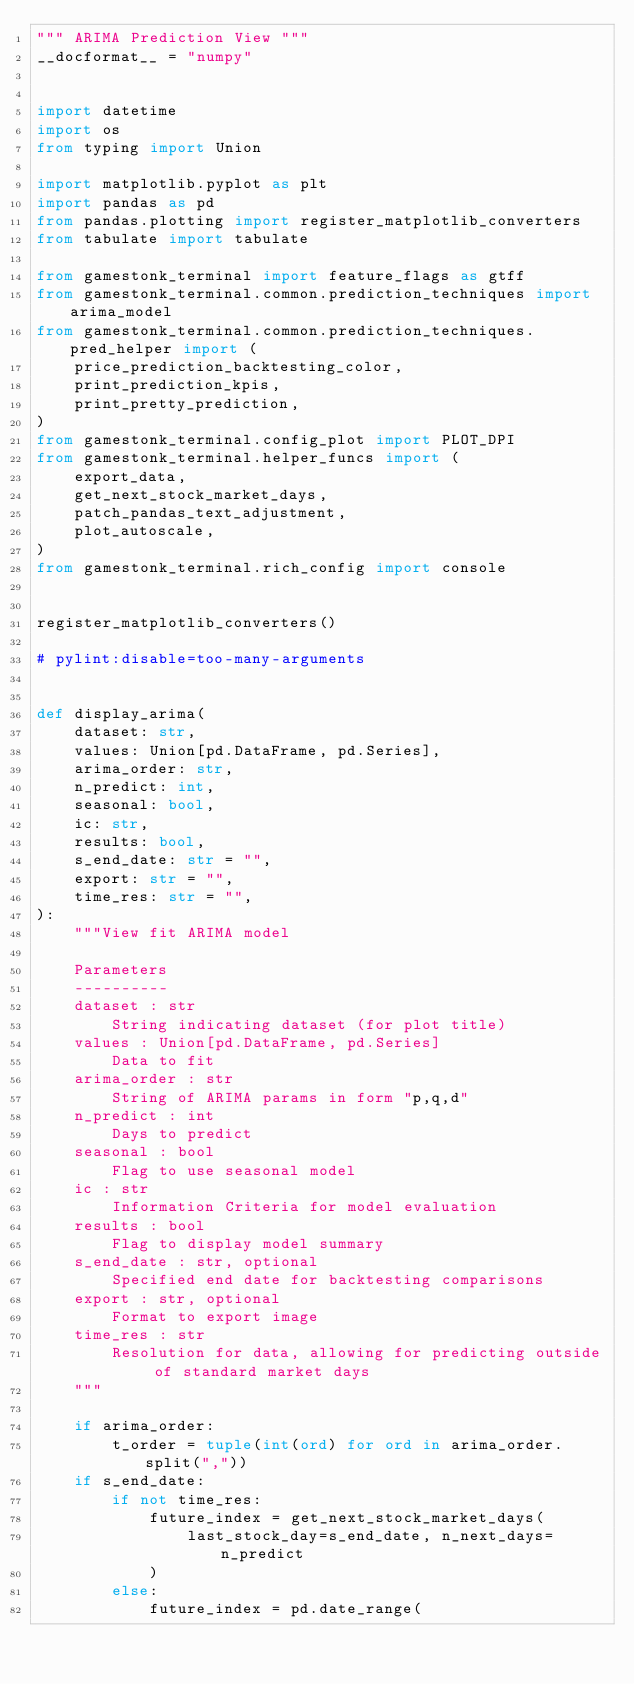Convert code to text. <code><loc_0><loc_0><loc_500><loc_500><_Python_>""" ARIMA Prediction View """
__docformat__ = "numpy"


import datetime
import os
from typing import Union

import matplotlib.pyplot as plt
import pandas as pd
from pandas.plotting import register_matplotlib_converters
from tabulate import tabulate

from gamestonk_terminal import feature_flags as gtff
from gamestonk_terminal.common.prediction_techniques import arima_model
from gamestonk_terminal.common.prediction_techniques.pred_helper import (
    price_prediction_backtesting_color,
    print_prediction_kpis,
    print_pretty_prediction,
)
from gamestonk_terminal.config_plot import PLOT_DPI
from gamestonk_terminal.helper_funcs import (
    export_data,
    get_next_stock_market_days,
    patch_pandas_text_adjustment,
    plot_autoscale,
)
from gamestonk_terminal.rich_config import console


register_matplotlib_converters()

# pylint:disable=too-many-arguments


def display_arima(
    dataset: str,
    values: Union[pd.DataFrame, pd.Series],
    arima_order: str,
    n_predict: int,
    seasonal: bool,
    ic: str,
    results: bool,
    s_end_date: str = "",
    export: str = "",
    time_res: str = "",
):
    """View fit ARIMA model

    Parameters
    ----------
    dataset : str
        String indicating dataset (for plot title)
    values : Union[pd.DataFrame, pd.Series]
        Data to fit
    arima_order : str
        String of ARIMA params in form "p,q,d"
    n_predict : int
        Days to predict
    seasonal : bool
        Flag to use seasonal model
    ic : str
        Information Criteria for model evaluation
    results : bool
        Flag to display model summary
    s_end_date : str, optional
        Specified end date for backtesting comparisons
    export : str, optional
        Format to export image
    time_res : str
        Resolution for data, allowing for predicting outside of standard market days
    """

    if arima_order:
        t_order = tuple(int(ord) for ord in arima_order.split(","))
    if s_end_date:
        if not time_res:
            future_index = get_next_stock_market_days(
                last_stock_day=s_end_date, n_next_days=n_predict
            )
        else:
            future_index = pd.date_range(</code> 